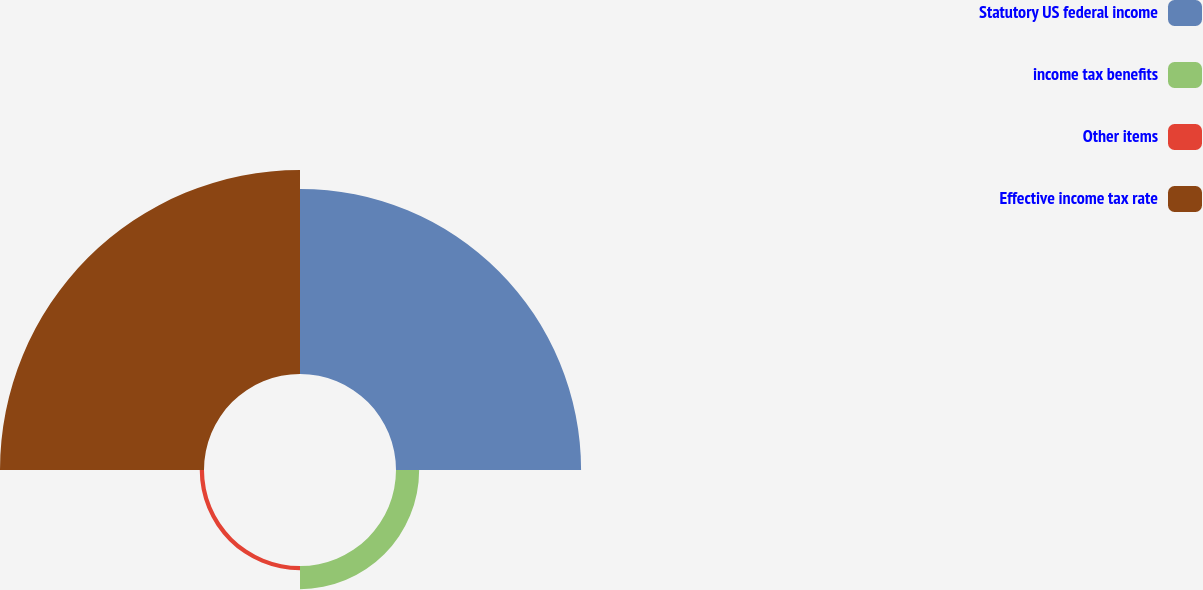Convert chart to OTSL. <chart><loc_0><loc_0><loc_500><loc_500><pie_chart><fcel>Statutory US federal income<fcel>income tax benefits<fcel>Other items<fcel>Effective income tax rate<nl><fcel>44.44%<fcel>5.56%<fcel>1.02%<fcel>48.98%<nl></chart> 